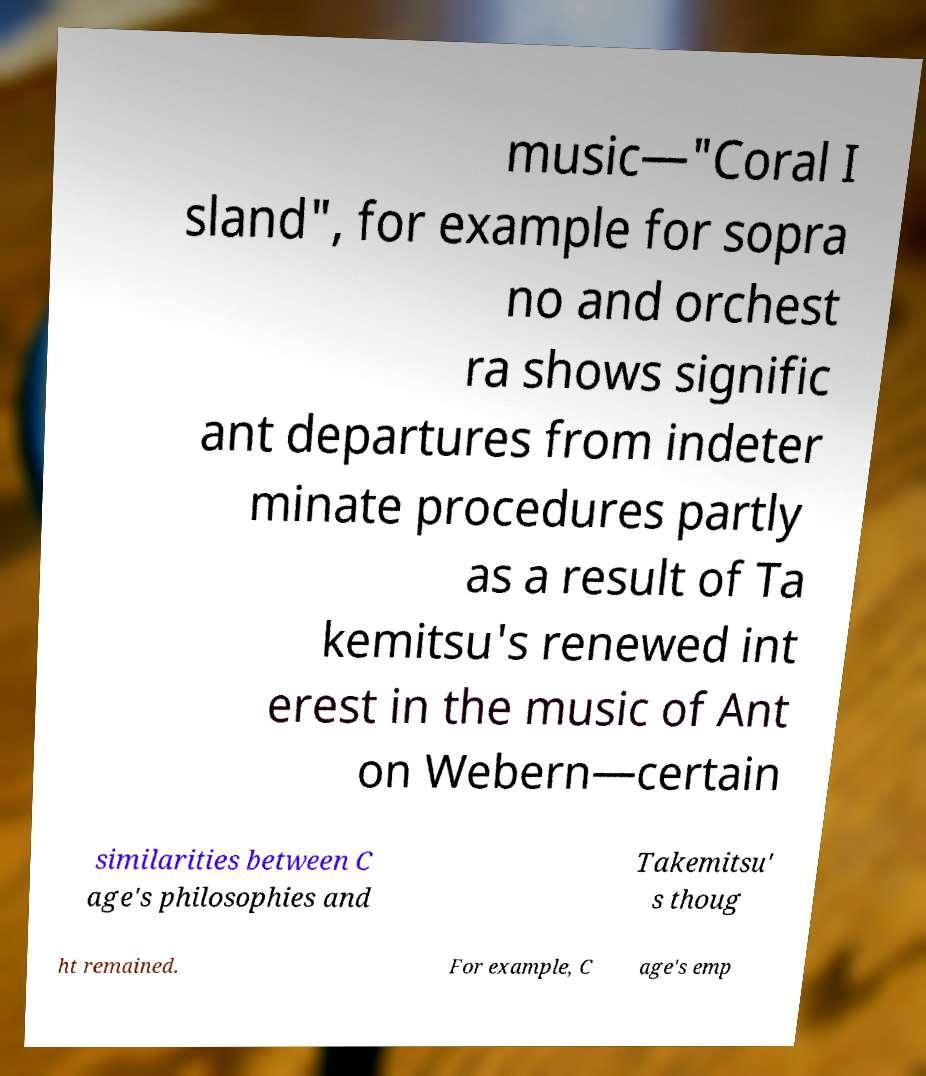Could you assist in decoding the text presented in this image and type it out clearly? music—"Coral I sland", for example for sopra no and orchest ra shows signific ant departures from indeter minate procedures partly as a result of Ta kemitsu's renewed int erest in the music of Ant on Webern—certain similarities between C age's philosophies and Takemitsu' s thoug ht remained. For example, C age's emp 